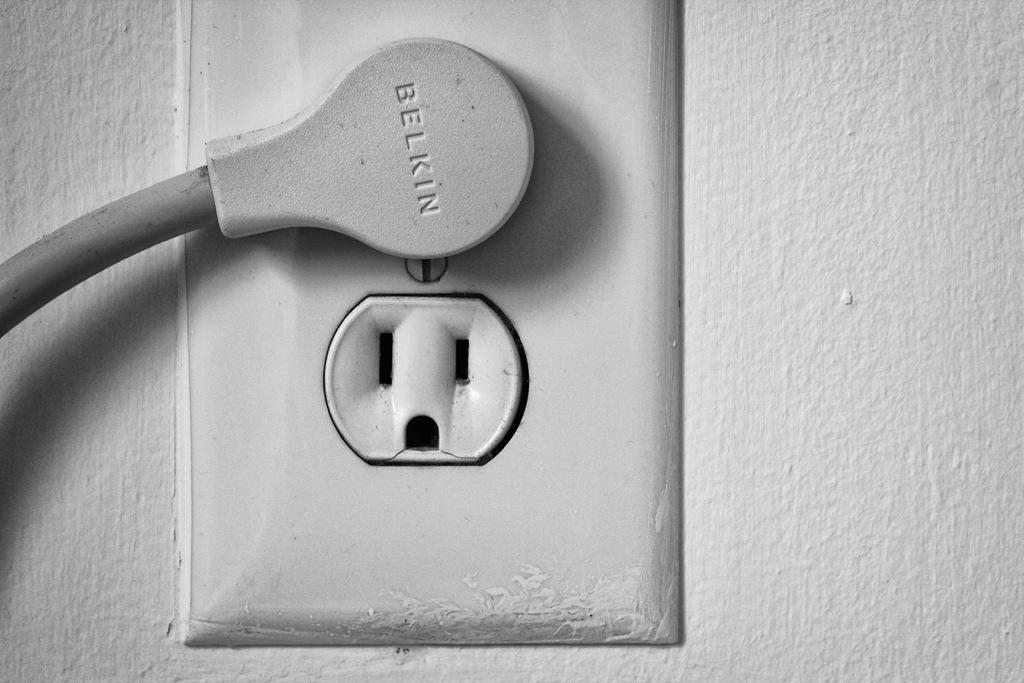Provide a one-sentence caption for the provided image. A plug on the wall, the plug is by Belkin and is gray. 